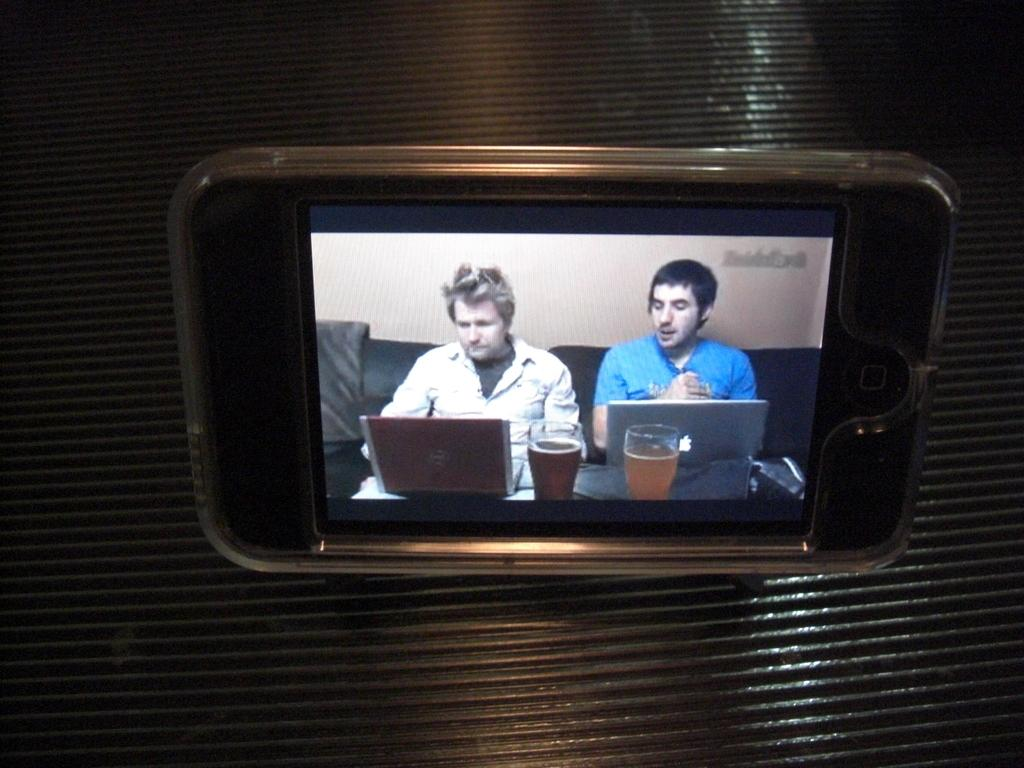What is hanging on an object in the image? There is a mobile on an object in the image. What is shown on the mobile's screen? The mobile's screen displays glasses with some liquid in them. What are the two persons in the image doing? The two persons are sitting on a couch and using laptops. What can be seen in the background of the image? There is a wall visible in the image. What type of jewel is being licked by the person's tongue in the image? There is no person or tongue present in the image, and no jewel is depicted. What color is the quartz on the wall in the image? There is no quartz present in the image; the wall is not described in terms of color or material. 